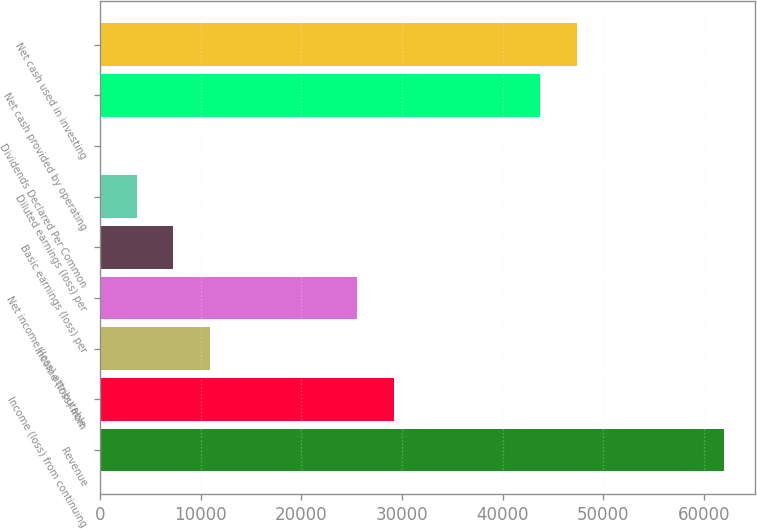Convert chart. <chart><loc_0><loc_0><loc_500><loc_500><bar_chart><fcel>Revenue<fcel>Income (loss) from continuing<fcel>Income (loss) from<fcel>Net income (loss) attributable<fcel>Basic earnings (loss) per<fcel>Diluted earnings (loss) per<fcel>Dividends Declared Per Common<fcel>Net cash provided by operating<fcel>Net cash used in investing<nl><fcel>61998.7<fcel>29176.1<fcel>10941.3<fcel>25529.1<fcel>7294.33<fcel>3647.37<fcel>0.41<fcel>43763.9<fcel>47410.9<nl></chart> 